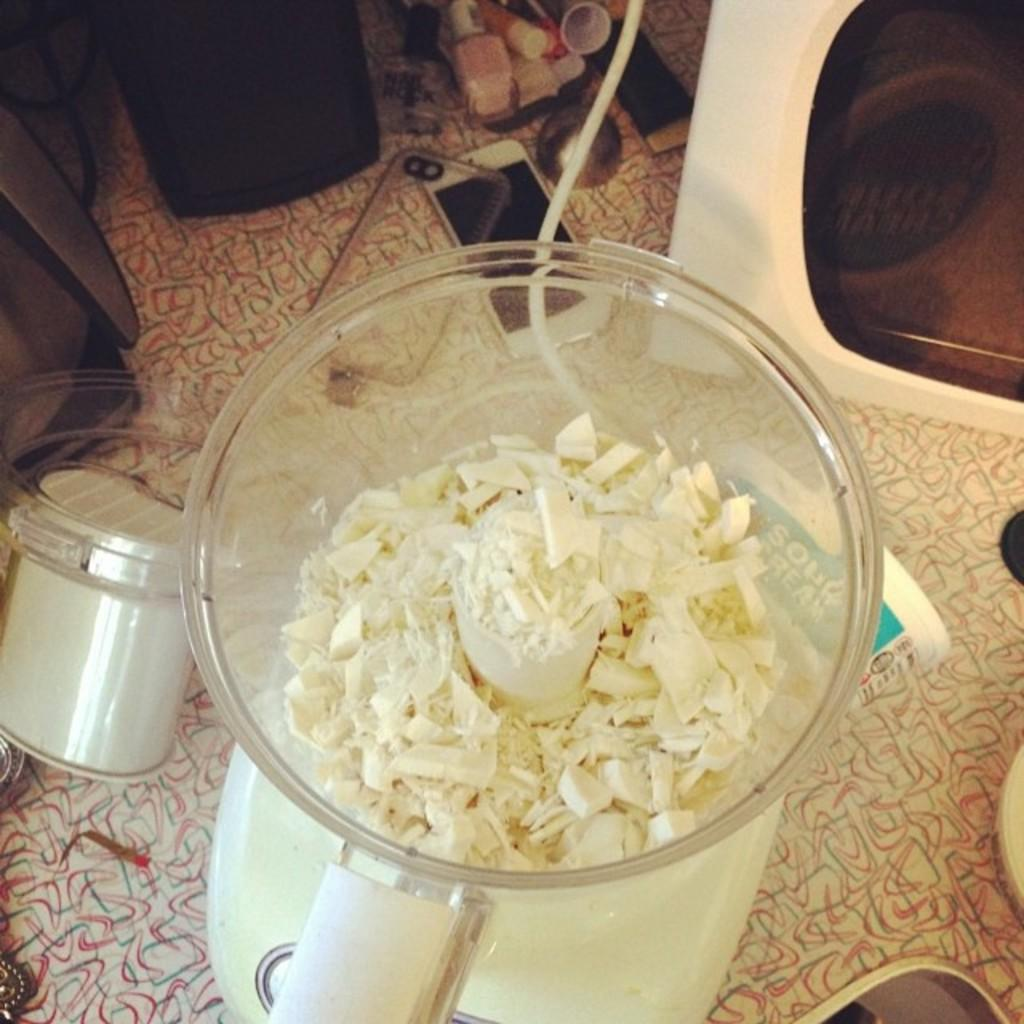What is the main object on the table in the image? There is a grinder on the table in the image. What other items can be seen on the table? There is a mobile phone, a container, a paper, and a black color object on the table in the image. What type of drain is visible in the image? There is no drain present in the image. Can you hear any sounds coming from the grinder in the image? The image is static, so it is not possible to hear any sounds from the grinder. 